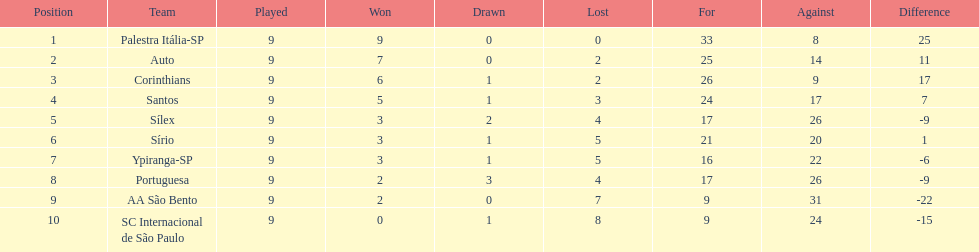In 1926 brazilian football, how many teams scored above 10 points in the season? 4. 